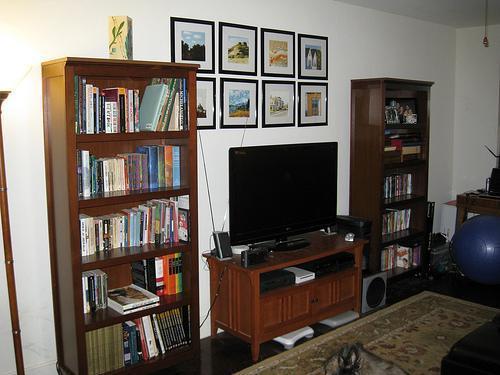How many picture frames are above the TV?
Give a very brief answer. 8. 